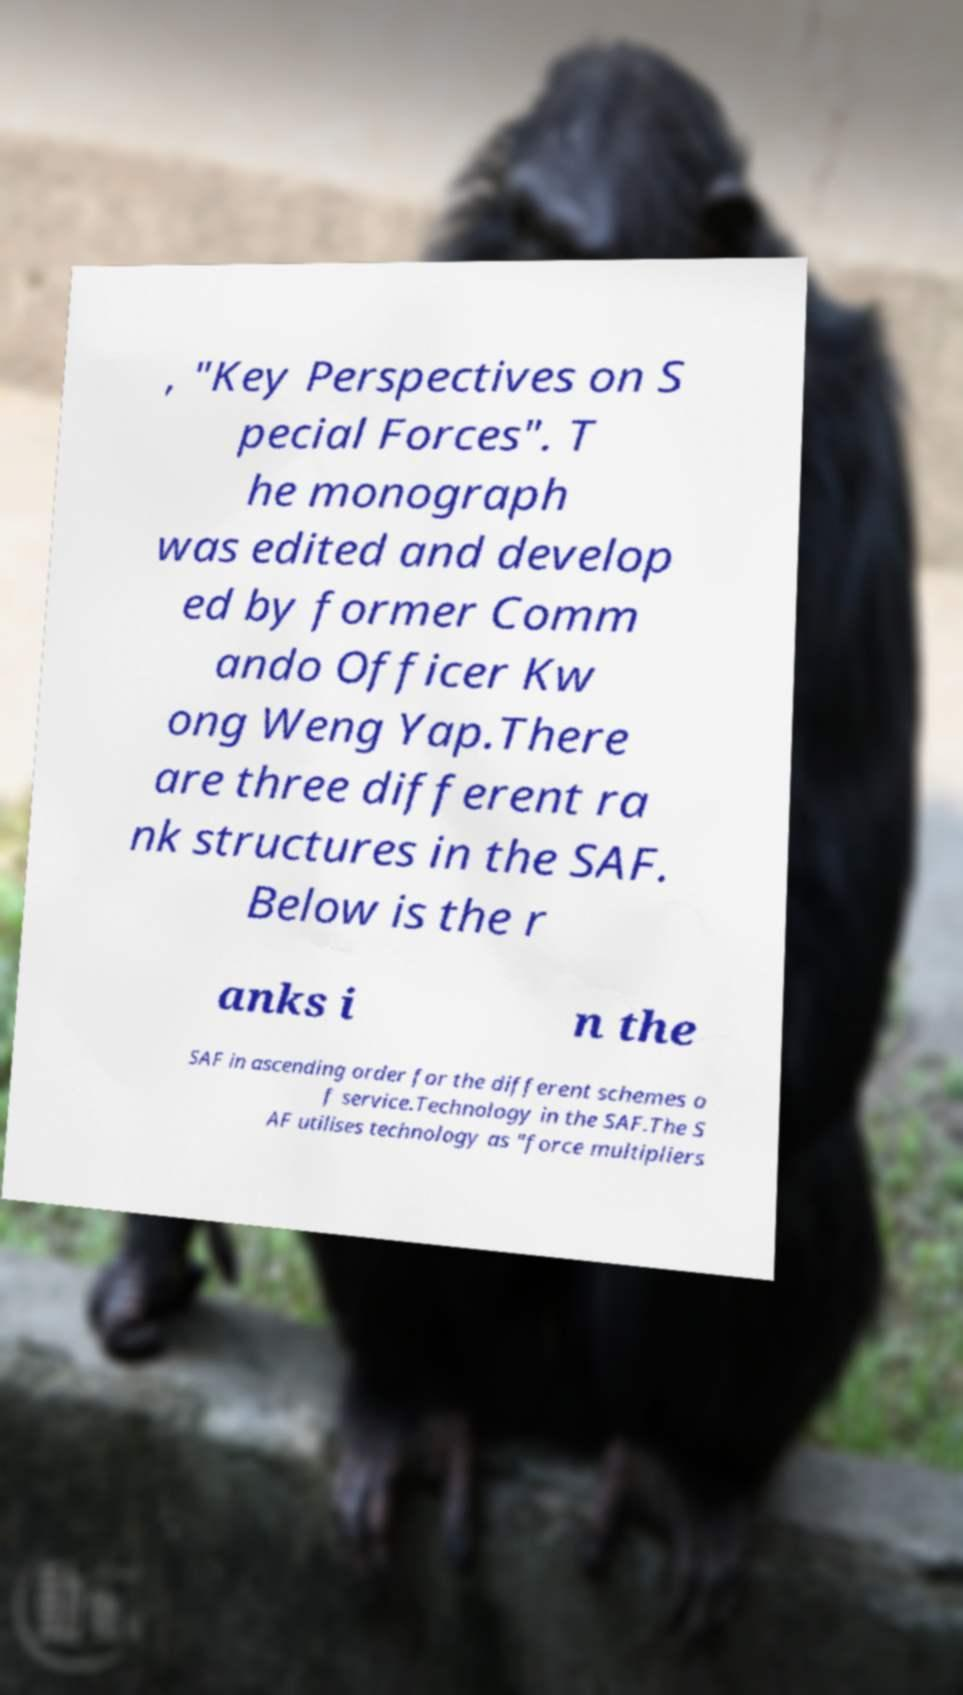Please identify and transcribe the text found in this image. , "Key Perspectives on S pecial Forces". T he monograph was edited and develop ed by former Comm ando Officer Kw ong Weng Yap.There are three different ra nk structures in the SAF. Below is the r anks i n the SAF in ascending order for the different schemes o f service.Technology in the SAF.The S AF utilises technology as "force multipliers 